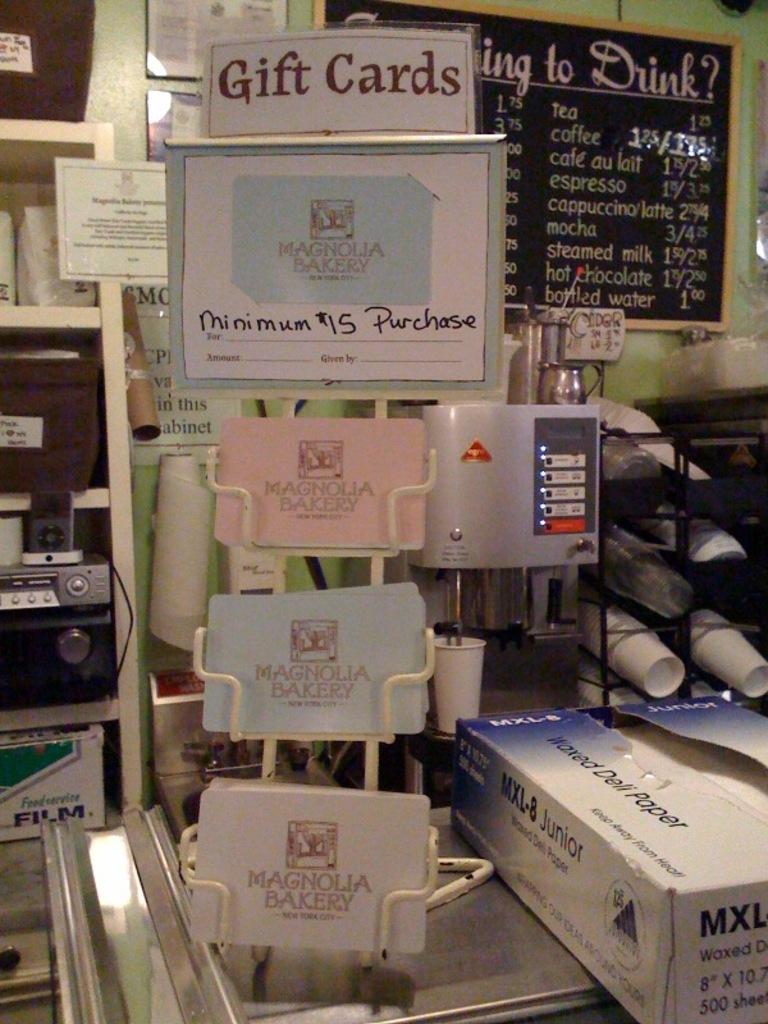<image>
Provide a brief description of the given image. A small rack of gift cards that require a minimum 15 dollar purchase 